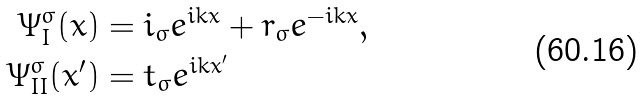<formula> <loc_0><loc_0><loc_500><loc_500>\Psi _ { I } ^ { \sigma } ( x ) & = i _ { \sigma } e ^ { i k x } + r _ { \sigma } e ^ { - i k x } , \\ \Psi _ { I I } ^ { \sigma } ( x ^ { \prime } ) & = t _ { \sigma } e ^ { i k x ^ { \prime } }</formula> 